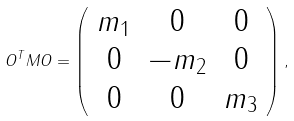<formula> <loc_0><loc_0><loc_500><loc_500>O ^ { T } M O = \left ( \begin{array} { c c c } m _ { 1 } & 0 & 0 \\ 0 & - m _ { 2 } & 0 \\ 0 & 0 & m _ { 3 } \\ \end{array} \right ) ,</formula> 